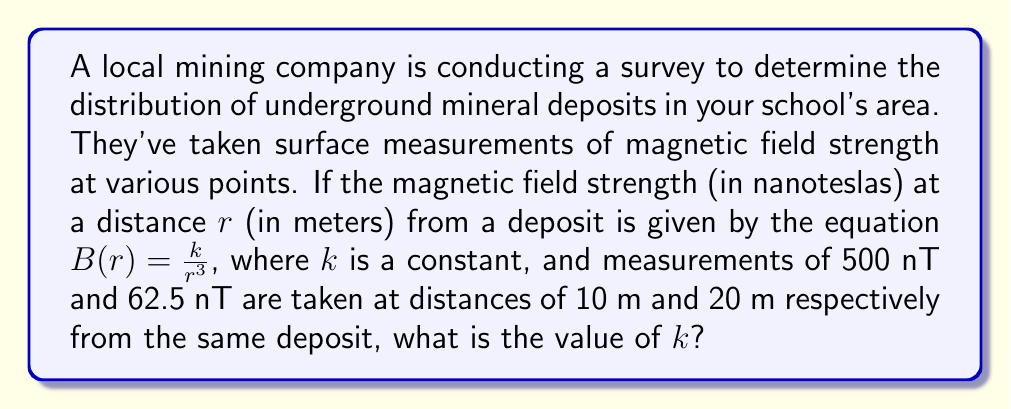Help me with this question. Let's approach this step-by-step:

1) We're given the equation $B(r) = \frac{k}{r^3}$, where:
   $B$ is the magnetic field strength in nanoteslas (nT)
   $r$ is the distance in meters (m)
   $k$ is a constant we need to find

2) We have two measurements:
   At $r_1 = 10$ m, $B_1 = 500$ nT
   At $r_2 = 20$ m, $B_2 = 62.5$ nT

3) Let's apply the equation to the first measurement:
   $500 = \frac{k}{10^3}$

4) Simplify:
   $500 = \frac{k}{1000}$

5) Multiply both sides by 1000:
   $500000 = k$

6) To verify, let's use this $k$ value with the second measurement:
   $62.5 = \frac{500000}{20^3}$

7) Simplify:
   $62.5 = \frac{500000}{8000} = 62.5$

This confirms that our calculated $k$ value is correct.
Answer: $k = 500000$ nT·m³ 